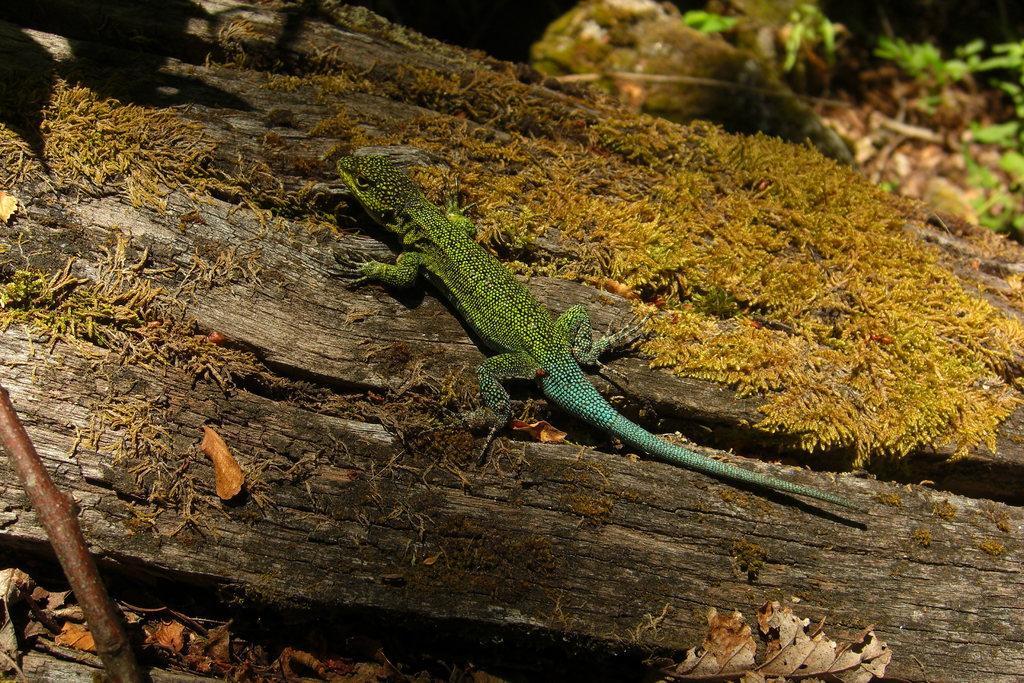Could you give a brief overview of what you see in this image? In this image we can see a reptile on the wooden log. Here we can see the dry leaves and this part of the image is slightly blurred. 